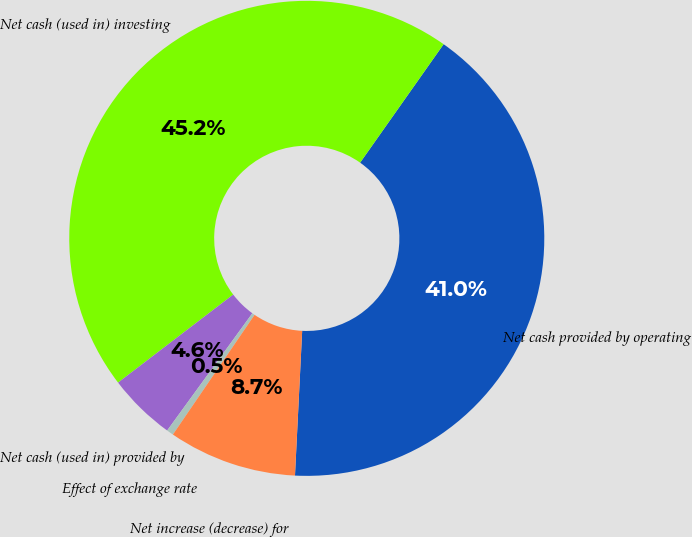<chart> <loc_0><loc_0><loc_500><loc_500><pie_chart><fcel>Net cash provided by operating<fcel>Net cash (used in) investing<fcel>Net cash (used in) provided by<fcel>Effect of exchange rate<fcel>Net increase (decrease) for<nl><fcel>41.02%<fcel>45.16%<fcel>4.61%<fcel>0.47%<fcel>8.74%<nl></chart> 